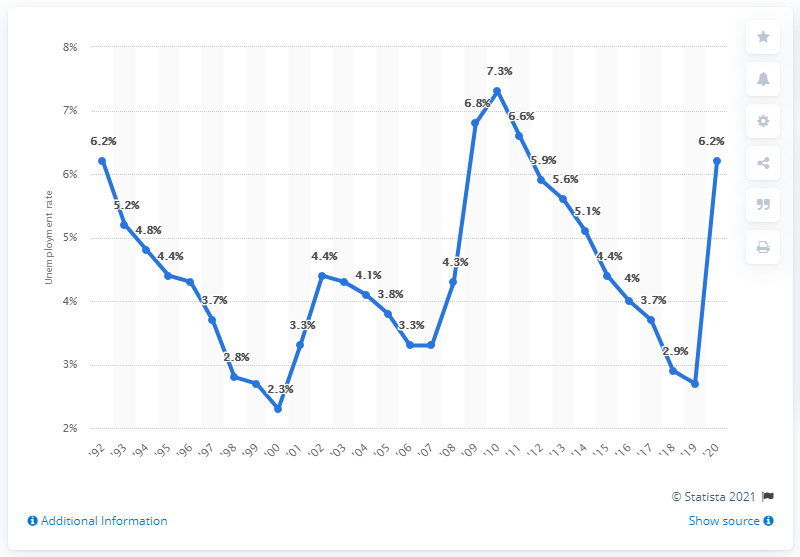Outline some significant characteristics in this image. In 2010, the unemployment rate was 2.7%. In 2010, the highest unemployment rate in the state of Virginia was 7.3%. The unemployment rate in Virginia in 2020 was 6.2%. 